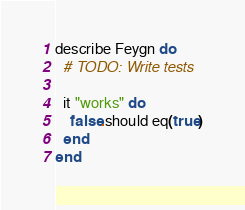Convert code to text. <code><loc_0><loc_0><loc_500><loc_500><_Crystal_>
describe Feygn do
  # TODO: Write tests

  it "works" do
    false.should eq(true)
  end
end
</code> 